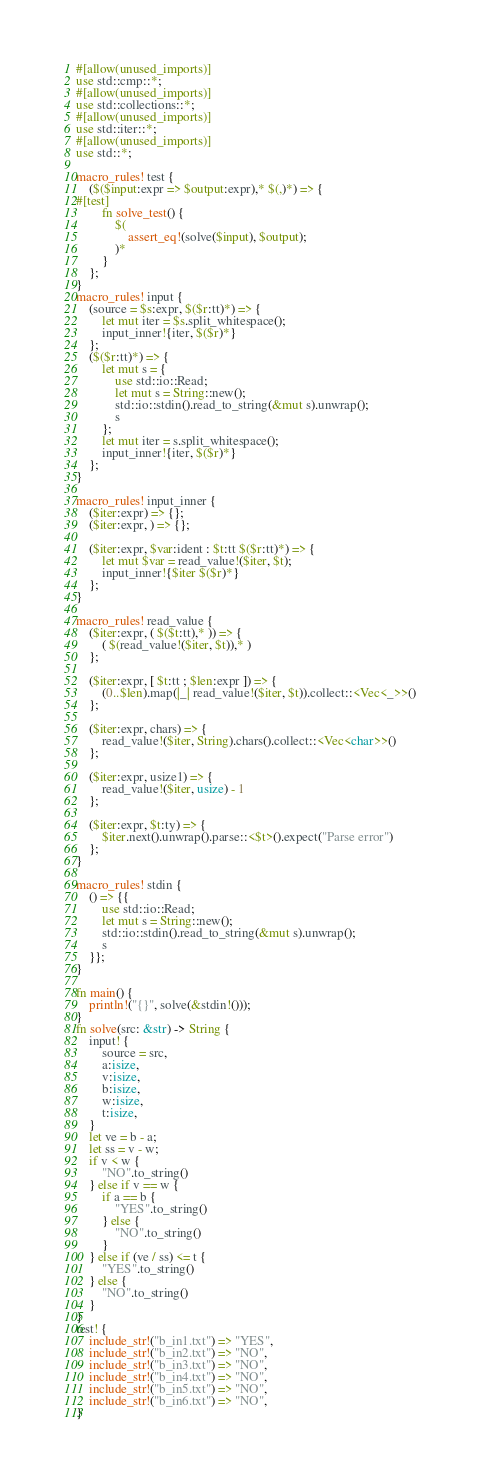<code> <loc_0><loc_0><loc_500><loc_500><_Rust_>#[allow(unused_imports)]
use std::cmp::*;
#[allow(unused_imports)]
use std::collections::*;
#[allow(unused_imports)]
use std::iter::*;
#[allow(unused_imports)]
use std::*;

macro_rules! test {
    ($($input:expr => $output:expr),* $(,)*) => {
#[test]
        fn solve_test() {
            $(
                assert_eq!(solve($input), $output);
            )*
        }
    };
}
macro_rules! input {
    (source = $s:expr, $($r:tt)*) => {
        let mut iter = $s.split_whitespace();
        input_inner!{iter, $($r)*}
    };
    ($($r:tt)*) => {
        let mut s = {
            use std::io::Read;
            let mut s = String::new();
            std::io::stdin().read_to_string(&mut s).unwrap();
            s
        };
        let mut iter = s.split_whitespace();
        input_inner!{iter, $($r)*}
    };
}

macro_rules! input_inner {
    ($iter:expr) => {};
    ($iter:expr, ) => {};

    ($iter:expr, $var:ident : $t:tt $($r:tt)*) => {
        let mut $var = read_value!($iter, $t);
        input_inner!{$iter $($r)*}
    };
}

macro_rules! read_value {
    ($iter:expr, ( $($t:tt),* )) => {
        ( $(read_value!($iter, $t)),* )
    };

    ($iter:expr, [ $t:tt ; $len:expr ]) => {
        (0..$len).map(|_| read_value!($iter, $t)).collect::<Vec<_>>()
    };

    ($iter:expr, chars) => {
        read_value!($iter, String).chars().collect::<Vec<char>>()
    };

    ($iter:expr, usize1) => {
        read_value!($iter, usize) - 1
    };

    ($iter:expr, $t:ty) => {
        $iter.next().unwrap().parse::<$t>().expect("Parse error")
    };
}

macro_rules! stdin {
    () => {{
        use std::io::Read;
        let mut s = String::new();
        std::io::stdin().read_to_string(&mut s).unwrap();
        s
    }};
}

fn main() {
    println!("{}", solve(&stdin!()));
}
fn solve(src: &str) -> String {
    input! {
        source = src,
        a:isize,
        v:isize,
        b:isize,
        w:isize,
        t:isize,
    }
    let ve = b - a;
    let ss = v - w;
    if v < w {
        "NO".to_string()
    } else if v == w {
        if a == b {
            "YES".to_string()
        } else {
            "NO".to_string()
        }
    } else if (ve / ss) <= t {
        "YES".to_string()
    } else {
        "NO".to_string()
    }
}
test! {
    include_str!("b_in1.txt") => "YES",
    include_str!("b_in2.txt") => "NO",
    include_str!("b_in3.txt") => "NO",
    include_str!("b_in4.txt") => "NO",
    include_str!("b_in5.txt") => "NO",
    include_str!("b_in6.txt") => "NO",
}
</code> 